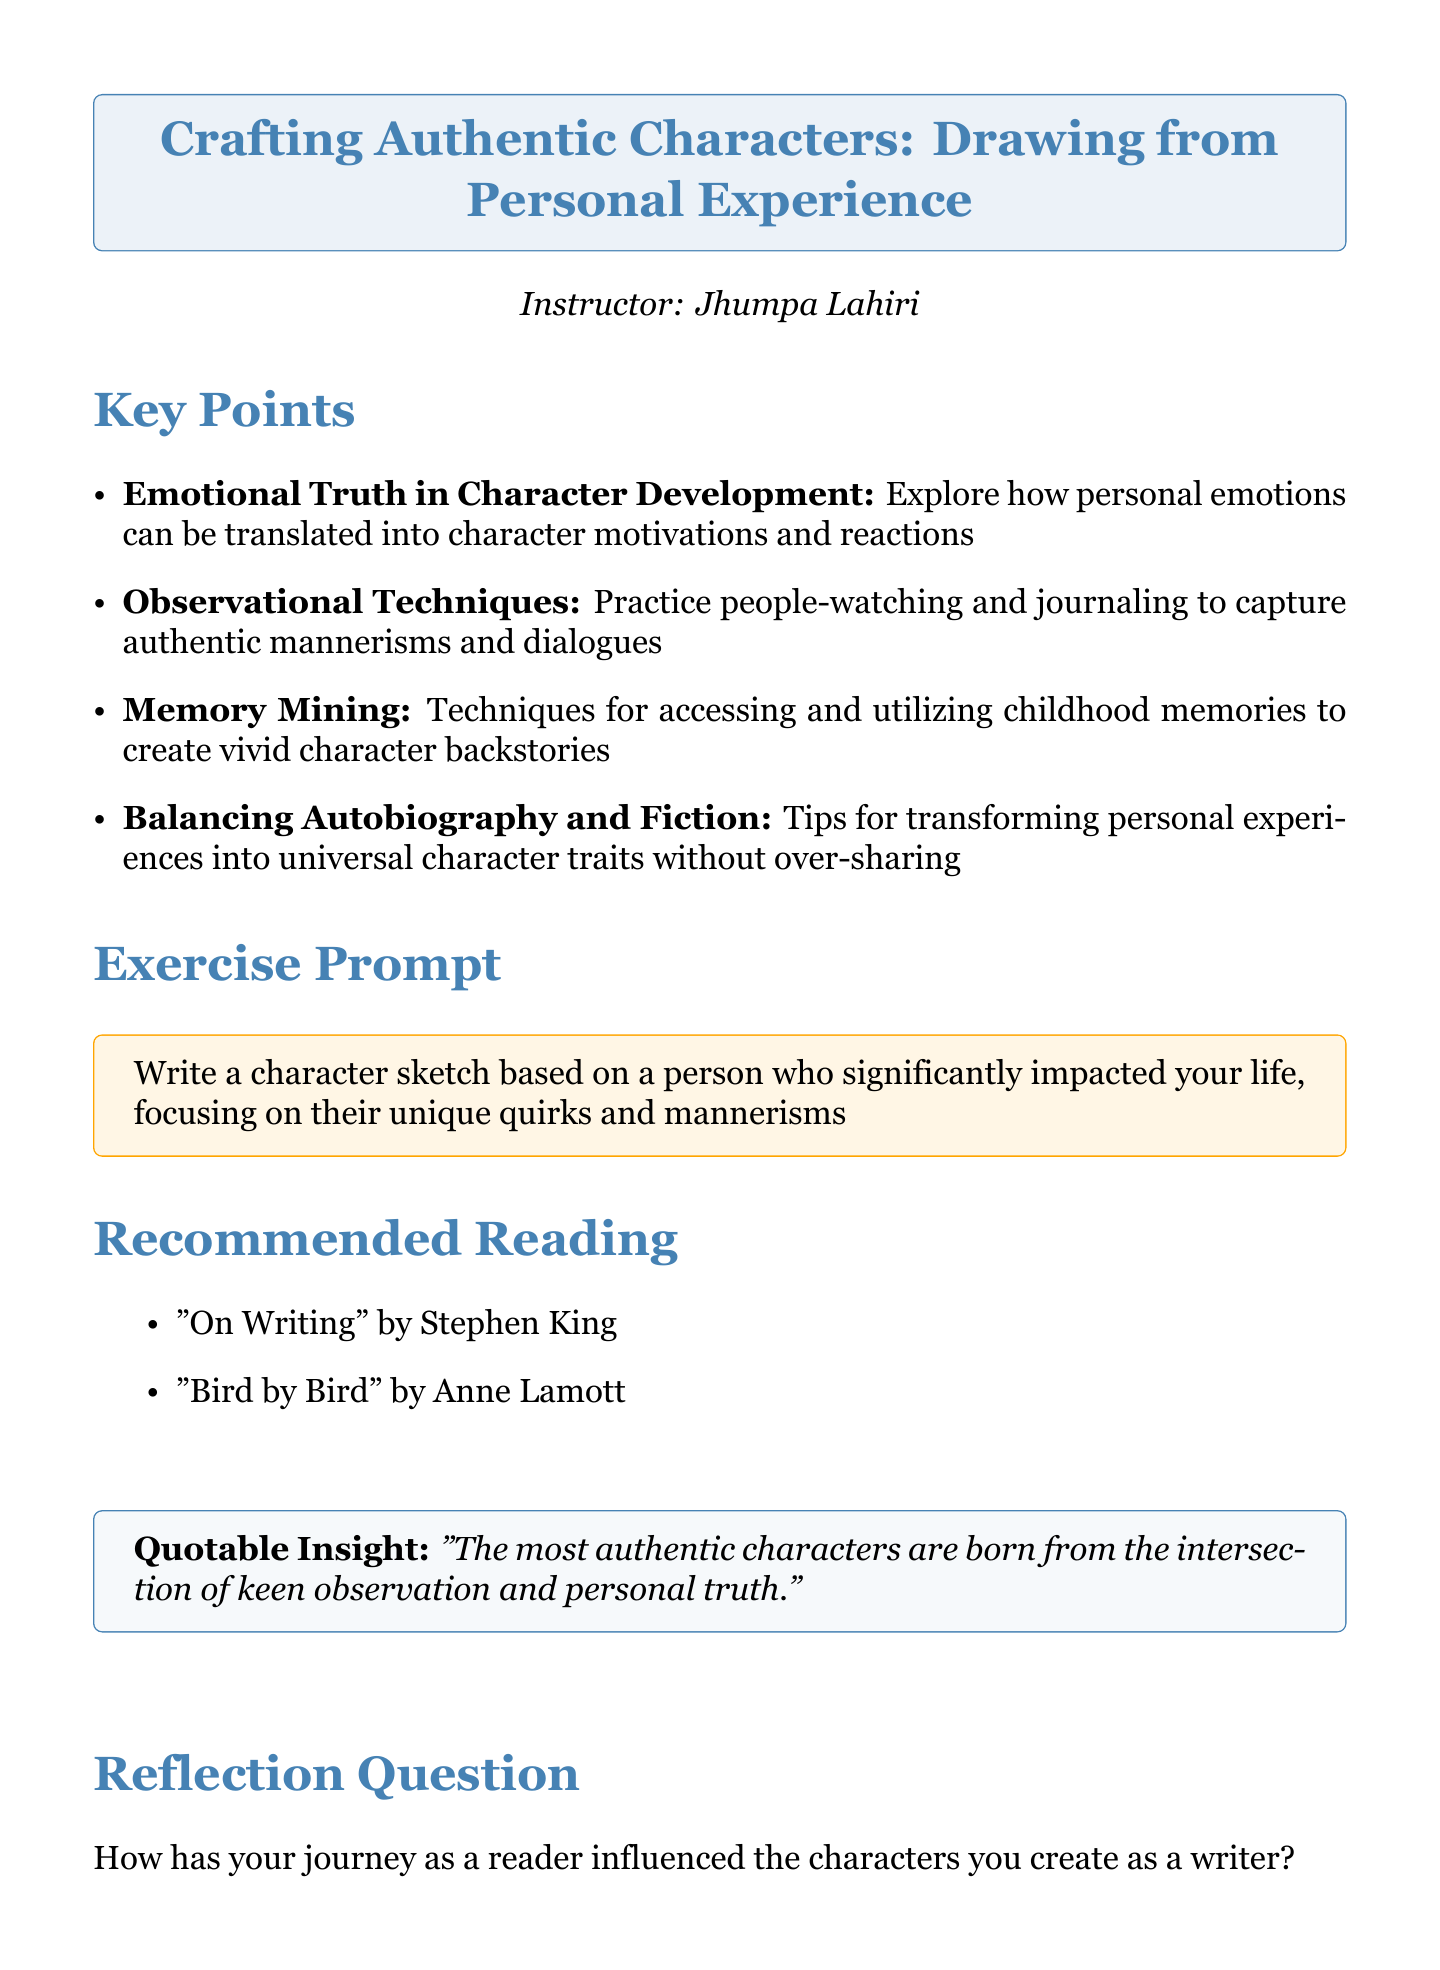What is the title of the workshop? The title of the workshop is presented as the main header in the document.
Answer: Crafting Authentic Characters: Drawing from Personal Experience Who is the instructor of the workshop? The document specifies the name of the workshop instructor prominently beneath the title.
Answer: Jhumpa Lahiri What is one key point related to emotional truth? The document lists several key points, one of which pertains to emotional truth in character development.
Answer: Personal emotions can be translated into character motivations and reactions What exercise prompt is provided? The document includes an exercise prompt directing participants on what to write about.
Answer: Write a character sketch based on a person who significantly impacted your life Name one book recommended for reading. Under the recommended reading section, the document lists titles and authors.
Answer: On Writing What is the quotable insight from the workshop? A quotable insight is highlighted in a specific colored box within the document.
Answer: The most authentic characters are born from the intersection of keen observation and personal truth How many key points are listed in the document? The number of key points can be counted from the bulleted list in the document.
Answer: Four What reflection question is posed at the end? The document concludes with a reflection question aimed at participants.
Answer: How has your journey as a reader influenced the characters you create as a writer? Which author wrote "Bird by Bird"? The document acknowledges the author associated with this recommended reading.
Answer: Anne Lamott 